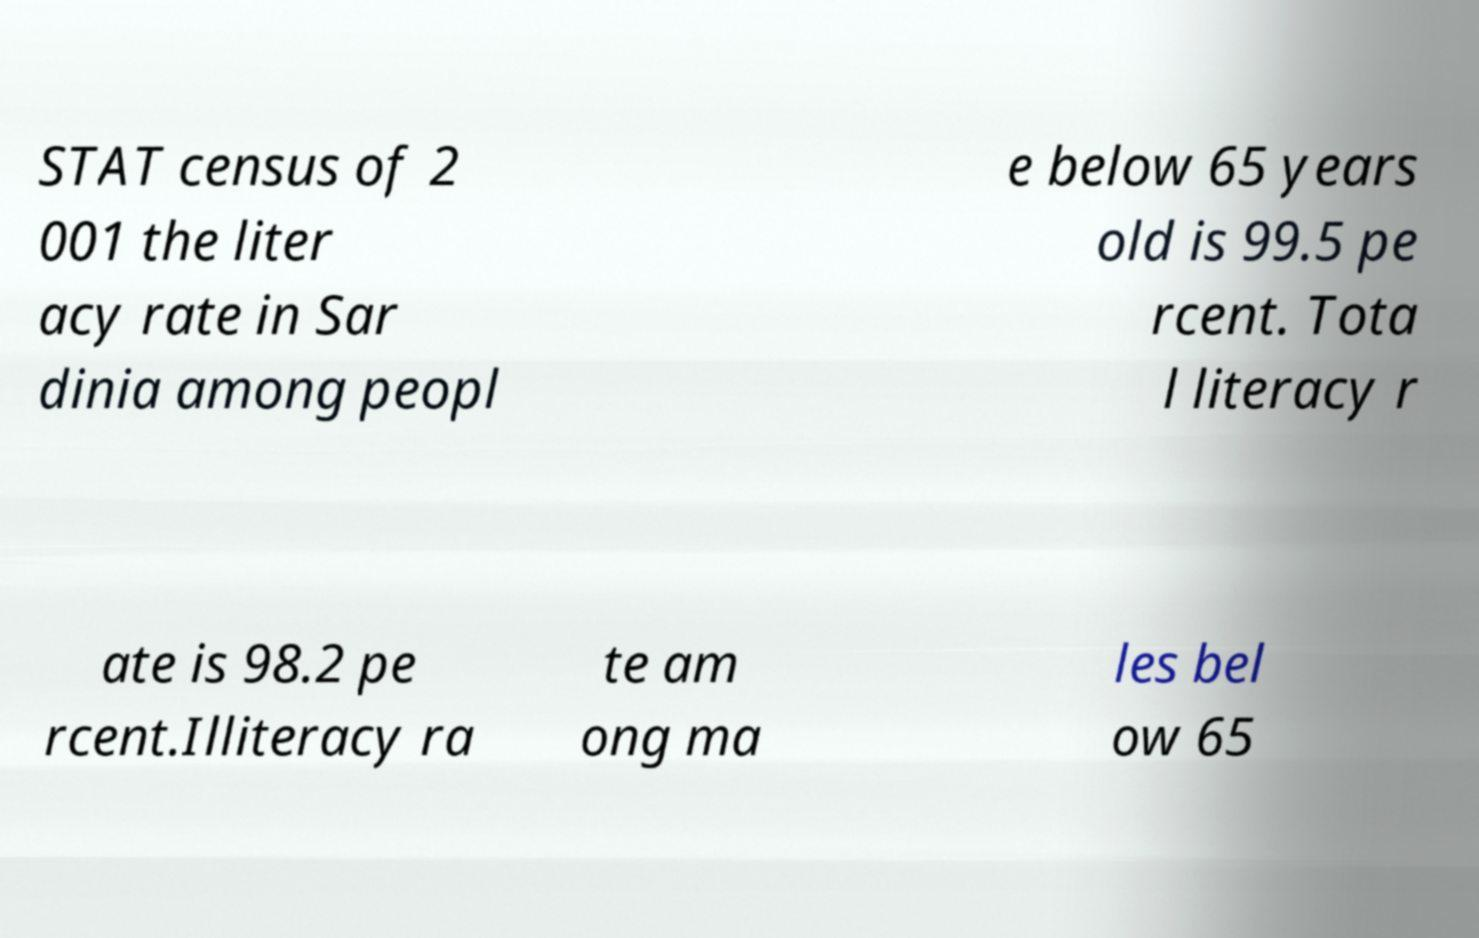Can you accurately transcribe the text from the provided image for me? STAT census of 2 001 the liter acy rate in Sar dinia among peopl e below 65 years old is 99.5 pe rcent. Tota l literacy r ate is 98.2 pe rcent.Illiteracy ra te am ong ma les bel ow 65 